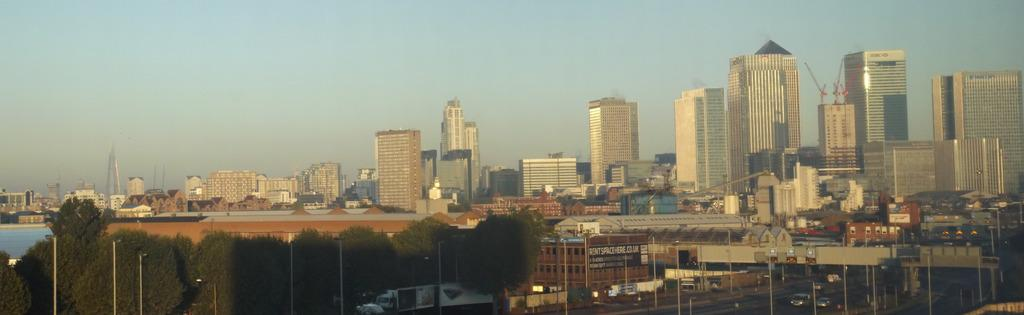What structures can be seen in the image? There are poles, vehicles, trees, buildings, and water visible in the image. Can you describe the type of vehicles in the image? The vehicles on the road in the image are not specified, but they are likely cars or trucks. What natural elements are present in the image? Trees and water are the natural elements present in the image. What type of structures can be seen in the background of the image? Buildings can be seen in the background of the image. What type of teaching is happening in the image? There is no teaching activity present in the image. Can you see any roses in the image? There are no roses visible in the image. 